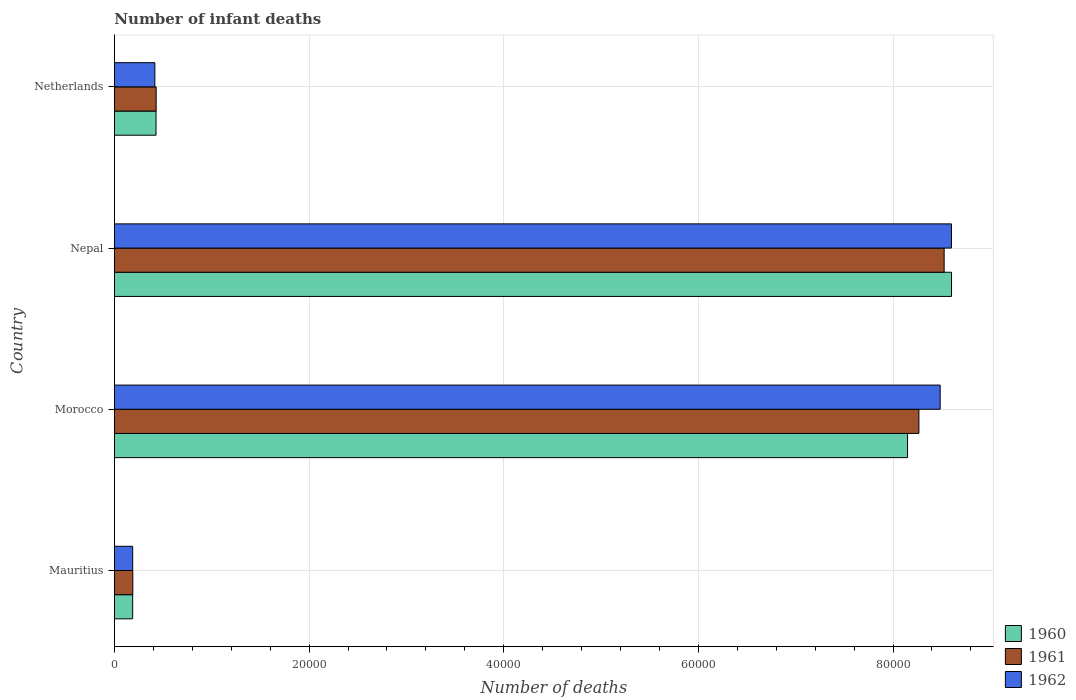How many groups of bars are there?
Your answer should be compact. 4. Are the number of bars on each tick of the Y-axis equal?
Give a very brief answer. Yes. How many bars are there on the 1st tick from the bottom?
Make the answer very short. 3. What is the number of infant deaths in 1960 in Mauritius?
Give a very brief answer. 1875. Across all countries, what is the maximum number of infant deaths in 1961?
Ensure brevity in your answer.  8.53e+04. Across all countries, what is the minimum number of infant deaths in 1961?
Keep it short and to the point. 1890. In which country was the number of infant deaths in 1962 maximum?
Provide a succinct answer. Nepal. In which country was the number of infant deaths in 1962 minimum?
Provide a short and direct response. Mauritius. What is the total number of infant deaths in 1961 in the graph?
Your answer should be very brief. 1.74e+05. What is the difference between the number of infant deaths in 1962 in Nepal and that in Netherlands?
Give a very brief answer. 8.19e+04. What is the difference between the number of infant deaths in 1960 in Netherlands and the number of infant deaths in 1961 in Mauritius?
Provide a short and direct response. 2385. What is the average number of infant deaths in 1960 per country?
Your answer should be very brief. 4.34e+04. What is the difference between the number of infant deaths in 1962 and number of infant deaths in 1961 in Morocco?
Make the answer very short. 2184. What is the ratio of the number of infant deaths in 1960 in Morocco to that in Nepal?
Make the answer very short. 0.95. Is the number of infant deaths in 1960 in Mauritius less than that in Netherlands?
Your answer should be very brief. Yes. Is the difference between the number of infant deaths in 1962 in Mauritius and Netherlands greater than the difference between the number of infant deaths in 1961 in Mauritius and Netherlands?
Make the answer very short. Yes. What is the difference between the highest and the second highest number of infant deaths in 1960?
Ensure brevity in your answer.  4516. What is the difference between the highest and the lowest number of infant deaths in 1962?
Make the answer very short. 8.41e+04. What does the 2nd bar from the bottom in Morocco represents?
Provide a short and direct response. 1961. Is it the case that in every country, the sum of the number of infant deaths in 1961 and number of infant deaths in 1962 is greater than the number of infant deaths in 1960?
Give a very brief answer. Yes. How many countries are there in the graph?
Give a very brief answer. 4. What is the difference between two consecutive major ticks on the X-axis?
Ensure brevity in your answer.  2.00e+04. Are the values on the major ticks of X-axis written in scientific E-notation?
Ensure brevity in your answer.  No. How are the legend labels stacked?
Your answer should be compact. Vertical. What is the title of the graph?
Your answer should be compact. Number of infant deaths. Does "1972" appear as one of the legend labels in the graph?
Keep it short and to the point. No. What is the label or title of the X-axis?
Keep it short and to the point. Number of deaths. What is the label or title of the Y-axis?
Offer a terse response. Country. What is the Number of deaths of 1960 in Mauritius?
Offer a very short reply. 1875. What is the Number of deaths of 1961 in Mauritius?
Provide a short and direct response. 1890. What is the Number of deaths in 1962 in Mauritius?
Offer a terse response. 1876. What is the Number of deaths in 1960 in Morocco?
Provide a succinct answer. 8.15e+04. What is the Number of deaths in 1961 in Morocco?
Your answer should be compact. 8.27e+04. What is the Number of deaths in 1962 in Morocco?
Your answer should be compact. 8.48e+04. What is the Number of deaths of 1960 in Nepal?
Your answer should be compact. 8.60e+04. What is the Number of deaths of 1961 in Nepal?
Ensure brevity in your answer.  8.53e+04. What is the Number of deaths in 1962 in Nepal?
Your response must be concise. 8.60e+04. What is the Number of deaths of 1960 in Netherlands?
Provide a short and direct response. 4275. What is the Number of deaths in 1961 in Netherlands?
Your response must be concise. 4288. What is the Number of deaths of 1962 in Netherlands?
Keep it short and to the point. 4155. Across all countries, what is the maximum Number of deaths of 1960?
Keep it short and to the point. 8.60e+04. Across all countries, what is the maximum Number of deaths in 1961?
Your response must be concise. 8.53e+04. Across all countries, what is the maximum Number of deaths of 1962?
Your answer should be very brief. 8.60e+04. Across all countries, what is the minimum Number of deaths in 1960?
Keep it short and to the point. 1875. Across all countries, what is the minimum Number of deaths in 1961?
Make the answer very short. 1890. Across all countries, what is the minimum Number of deaths in 1962?
Give a very brief answer. 1876. What is the total Number of deaths of 1960 in the graph?
Provide a short and direct response. 1.74e+05. What is the total Number of deaths in 1961 in the graph?
Offer a very short reply. 1.74e+05. What is the total Number of deaths in 1962 in the graph?
Your answer should be compact. 1.77e+05. What is the difference between the Number of deaths of 1960 in Mauritius and that in Morocco?
Your answer should be compact. -7.96e+04. What is the difference between the Number of deaths of 1961 in Mauritius and that in Morocco?
Provide a short and direct response. -8.08e+04. What is the difference between the Number of deaths of 1962 in Mauritius and that in Morocco?
Provide a short and direct response. -8.30e+04. What is the difference between the Number of deaths in 1960 in Mauritius and that in Nepal?
Offer a terse response. -8.41e+04. What is the difference between the Number of deaths of 1961 in Mauritius and that in Nepal?
Make the answer very short. -8.34e+04. What is the difference between the Number of deaths in 1962 in Mauritius and that in Nepal?
Ensure brevity in your answer.  -8.41e+04. What is the difference between the Number of deaths in 1960 in Mauritius and that in Netherlands?
Give a very brief answer. -2400. What is the difference between the Number of deaths in 1961 in Mauritius and that in Netherlands?
Your answer should be very brief. -2398. What is the difference between the Number of deaths of 1962 in Mauritius and that in Netherlands?
Give a very brief answer. -2279. What is the difference between the Number of deaths in 1960 in Morocco and that in Nepal?
Offer a terse response. -4516. What is the difference between the Number of deaths of 1961 in Morocco and that in Nepal?
Ensure brevity in your answer.  -2593. What is the difference between the Number of deaths in 1962 in Morocco and that in Nepal?
Your answer should be compact. -1161. What is the difference between the Number of deaths of 1960 in Morocco and that in Netherlands?
Ensure brevity in your answer.  7.72e+04. What is the difference between the Number of deaths of 1961 in Morocco and that in Netherlands?
Your answer should be compact. 7.84e+04. What is the difference between the Number of deaths in 1962 in Morocco and that in Netherlands?
Make the answer very short. 8.07e+04. What is the difference between the Number of deaths of 1960 in Nepal and that in Netherlands?
Give a very brief answer. 8.17e+04. What is the difference between the Number of deaths of 1961 in Nepal and that in Netherlands?
Your answer should be very brief. 8.10e+04. What is the difference between the Number of deaths of 1962 in Nepal and that in Netherlands?
Ensure brevity in your answer.  8.19e+04. What is the difference between the Number of deaths in 1960 in Mauritius and the Number of deaths in 1961 in Morocco?
Provide a succinct answer. -8.08e+04. What is the difference between the Number of deaths of 1960 in Mauritius and the Number of deaths of 1962 in Morocco?
Provide a short and direct response. -8.30e+04. What is the difference between the Number of deaths in 1961 in Mauritius and the Number of deaths in 1962 in Morocco?
Make the answer very short. -8.30e+04. What is the difference between the Number of deaths in 1960 in Mauritius and the Number of deaths in 1961 in Nepal?
Ensure brevity in your answer.  -8.34e+04. What is the difference between the Number of deaths of 1960 in Mauritius and the Number of deaths of 1962 in Nepal?
Your response must be concise. -8.41e+04. What is the difference between the Number of deaths of 1961 in Mauritius and the Number of deaths of 1962 in Nepal?
Make the answer very short. -8.41e+04. What is the difference between the Number of deaths of 1960 in Mauritius and the Number of deaths of 1961 in Netherlands?
Ensure brevity in your answer.  -2413. What is the difference between the Number of deaths in 1960 in Mauritius and the Number of deaths in 1962 in Netherlands?
Provide a succinct answer. -2280. What is the difference between the Number of deaths in 1961 in Mauritius and the Number of deaths in 1962 in Netherlands?
Make the answer very short. -2265. What is the difference between the Number of deaths in 1960 in Morocco and the Number of deaths in 1961 in Nepal?
Give a very brief answer. -3759. What is the difference between the Number of deaths in 1960 in Morocco and the Number of deaths in 1962 in Nepal?
Offer a very short reply. -4511. What is the difference between the Number of deaths of 1961 in Morocco and the Number of deaths of 1962 in Nepal?
Your response must be concise. -3345. What is the difference between the Number of deaths in 1960 in Morocco and the Number of deaths in 1961 in Netherlands?
Offer a very short reply. 7.72e+04. What is the difference between the Number of deaths in 1960 in Morocco and the Number of deaths in 1962 in Netherlands?
Make the answer very short. 7.73e+04. What is the difference between the Number of deaths in 1961 in Morocco and the Number of deaths in 1962 in Netherlands?
Your answer should be very brief. 7.85e+04. What is the difference between the Number of deaths of 1960 in Nepal and the Number of deaths of 1961 in Netherlands?
Make the answer very short. 8.17e+04. What is the difference between the Number of deaths in 1960 in Nepal and the Number of deaths in 1962 in Netherlands?
Your response must be concise. 8.19e+04. What is the difference between the Number of deaths in 1961 in Nepal and the Number of deaths in 1962 in Netherlands?
Offer a very short reply. 8.11e+04. What is the average Number of deaths of 1960 per country?
Offer a terse response. 4.34e+04. What is the average Number of deaths in 1961 per country?
Offer a terse response. 4.35e+04. What is the average Number of deaths of 1962 per country?
Give a very brief answer. 4.42e+04. What is the difference between the Number of deaths of 1960 and Number of deaths of 1962 in Mauritius?
Keep it short and to the point. -1. What is the difference between the Number of deaths of 1960 and Number of deaths of 1961 in Morocco?
Make the answer very short. -1166. What is the difference between the Number of deaths of 1960 and Number of deaths of 1962 in Morocco?
Your response must be concise. -3350. What is the difference between the Number of deaths in 1961 and Number of deaths in 1962 in Morocco?
Your response must be concise. -2184. What is the difference between the Number of deaths in 1960 and Number of deaths in 1961 in Nepal?
Your answer should be very brief. 757. What is the difference between the Number of deaths of 1961 and Number of deaths of 1962 in Nepal?
Give a very brief answer. -752. What is the difference between the Number of deaths of 1960 and Number of deaths of 1961 in Netherlands?
Provide a short and direct response. -13. What is the difference between the Number of deaths of 1960 and Number of deaths of 1962 in Netherlands?
Offer a terse response. 120. What is the difference between the Number of deaths of 1961 and Number of deaths of 1962 in Netherlands?
Your answer should be very brief. 133. What is the ratio of the Number of deaths in 1960 in Mauritius to that in Morocco?
Offer a terse response. 0.02. What is the ratio of the Number of deaths of 1961 in Mauritius to that in Morocco?
Your answer should be very brief. 0.02. What is the ratio of the Number of deaths in 1962 in Mauritius to that in Morocco?
Your answer should be compact. 0.02. What is the ratio of the Number of deaths in 1960 in Mauritius to that in Nepal?
Offer a very short reply. 0.02. What is the ratio of the Number of deaths in 1961 in Mauritius to that in Nepal?
Give a very brief answer. 0.02. What is the ratio of the Number of deaths in 1962 in Mauritius to that in Nepal?
Your response must be concise. 0.02. What is the ratio of the Number of deaths of 1960 in Mauritius to that in Netherlands?
Offer a terse response. 0.44. What is the ratio of the Number of deaths of 1961 in Mauritius to that in Netherlands?
Your response must be concise. 0.44. What is the ratio of the Number of deaths in 1962 in Mauritius to that in Netherlands?
Offer a terse response. 0.45. What is the ratio of the Number of deaths in 1960 in Morocco to that in Nepal?
Ensure brevity in your answer.  0.95. What is the ratio of the Number of deaths in 1961 in Morocco to that in Nepal?
Ensure brevity in your answer.  0.97. What is the ratio of the Number of deaths of 1962 in Morocco to that in Nepal?
Give a very brief answer. 0.99. What is the ratio of the Number of deaths in 1960 in Morocco to that in Netherlands?
Keep it short and to the point. 19.06. What is the ratio of the Number of deaths of 1961 in Morocco to that in Netherlands?
Your response must be concise. 19.28. What is the ratio of the Number of deaths of 1962 in Morocco to that in Netherlands?
Ensure brevity in your answer.  20.42. What is the ratio of the Number of deaths of 1960 in Nepal to that in Netherlands?
Make the answer very short. 20.12. What is the ratio of the Number of deaths of 1961 in Nepal to that in Netherlands?
Provide a succinct answer. 19.88. What is the ratio of the Number of deaths of 1962 in Nepal to that in Netherlands?
Your answer should be compact. 20.7. What is the difference between the highest and the second highest Number of deaths of 1960?
Make the answer very short. 4516. What is the difference between the highest and the second highest Number of deaths of 1961?
Make the answer very short. 2593. What is the difference between the highest and the second highest Number of deaths in 1962?
Give a very brief answer. 1161. What is the difference between the highest and the lowest Number of deaths in 1960?
Provide a short and direct response. 8.41e+04. What is the difference between the highest and the lowest Number of deaths of 1961?
Provide a succinct answer. 8.34e+04. What is the difference between the highest and the lowest Number of deaths of 1962?
Your response must be concise. 8.41e+04. 